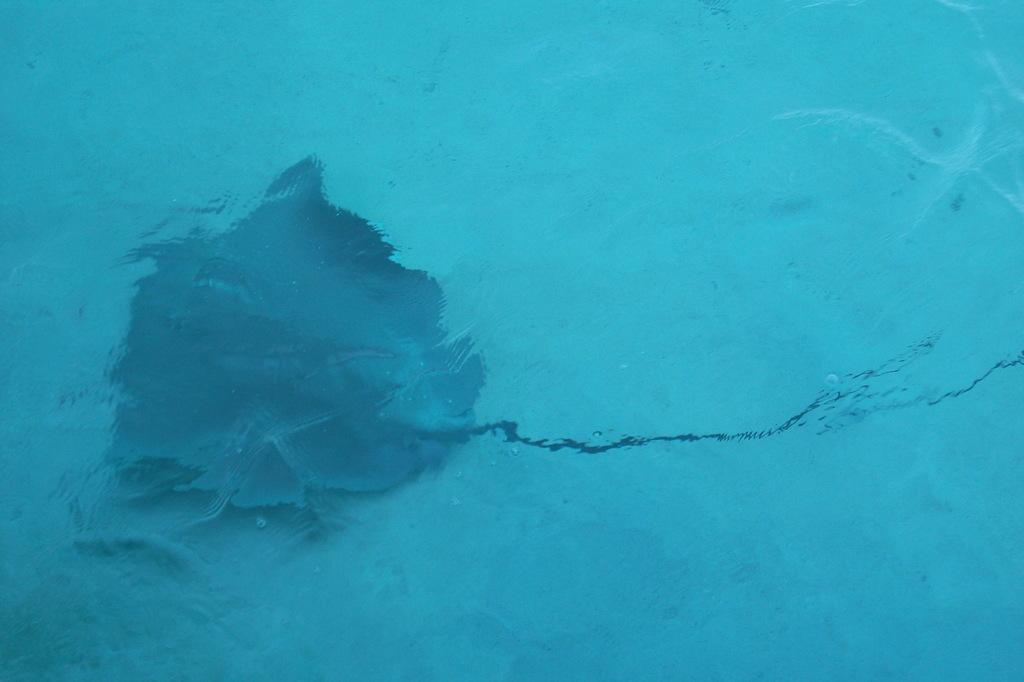What is the primary element in the image? There is water in the image. What is the color of the water? The water is blue in color. Can you describe any objects in the image? There is an object in the image that is black in color and below the water level. What type of lettuce can be seen floating on the water's surface in the image? There is no lettuce present in the image; it only features water and an object below the water level. 